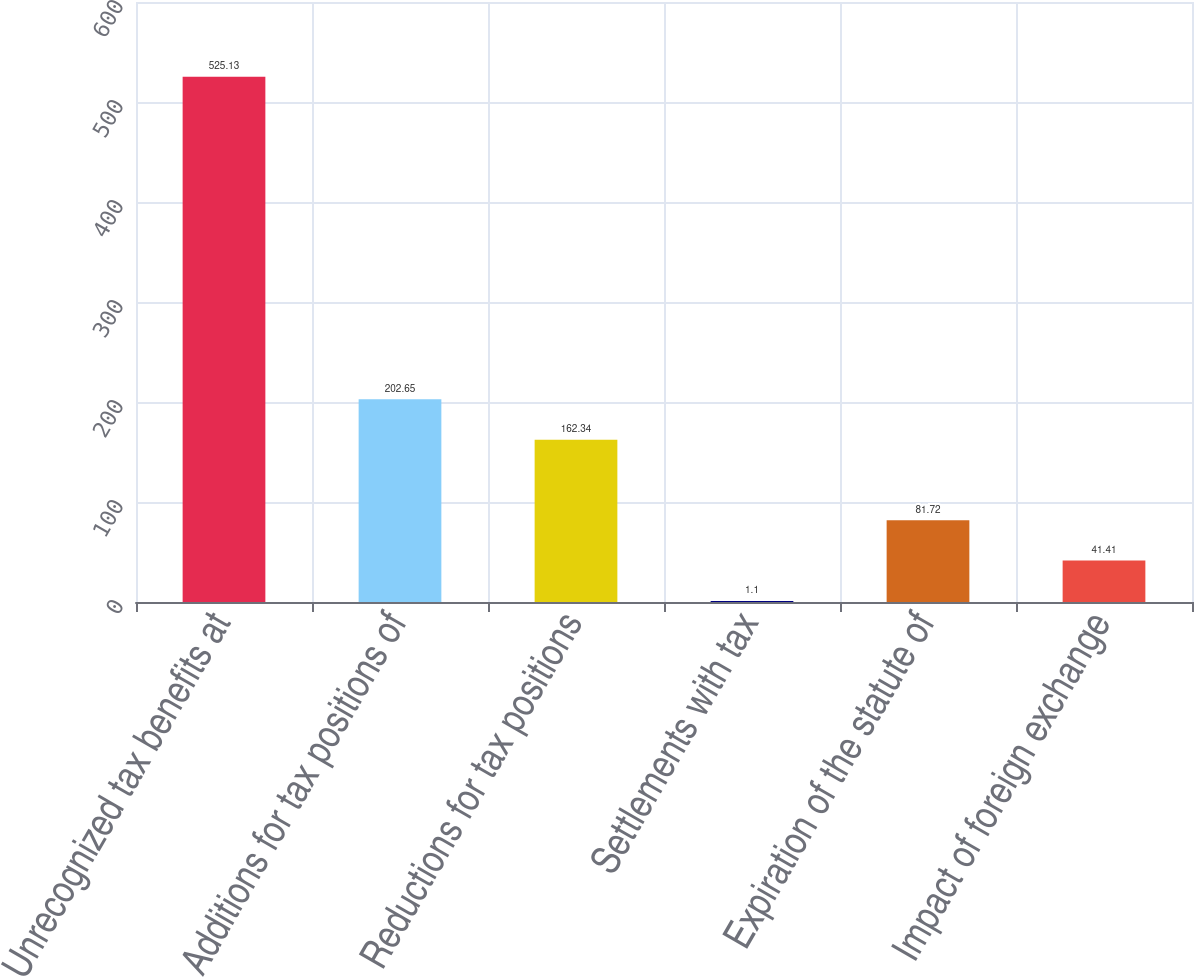Convert chart. <chart><loc_0><loc_0><loc_500><loc_500><bar_chart><fcel>Unrecognized tax benefits at<fcel>Additions for tax positions of<fcel>Reductions for tax positions<fcel>Settlements with tax<fcel>Expiration of the statute of<fcel>Impact of foreign exchange<nl><fcel>525.13<fcel>202.65<fcel>162.34<fcel>1.1<fcel>81.72<fcel>41.41<nl></chart> 